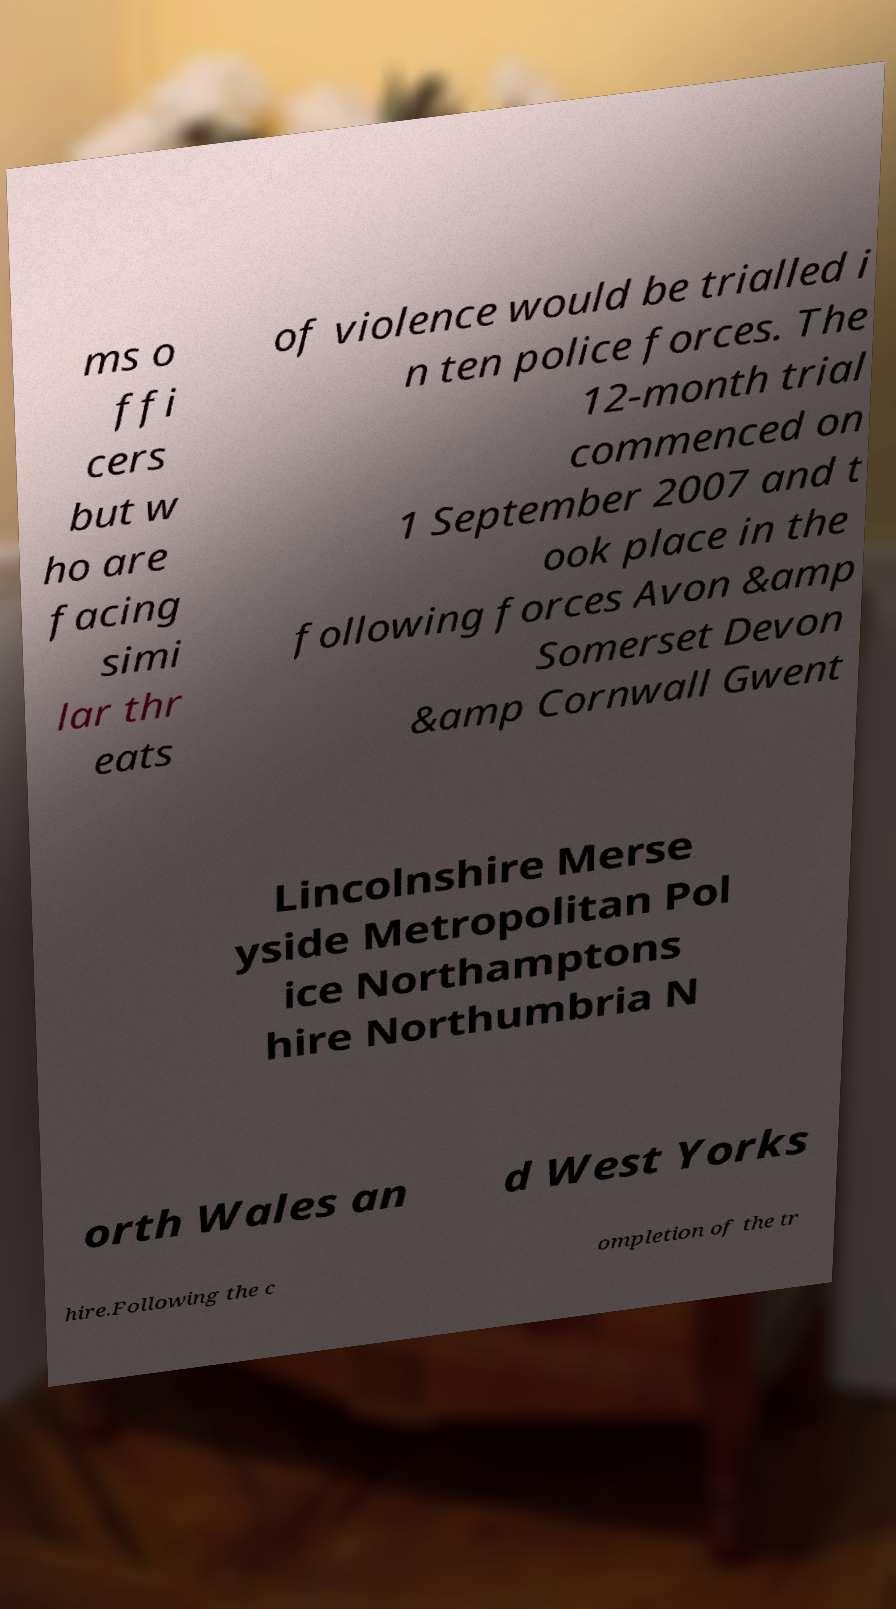Please read and relay the text visible in this image. What does it say? ms o ffi cers but w ho are facing simi lar thr eats of violence would be trialled i n ten police forces. The 12-month trial commenced on 1 September 2007 and t ook place in the following forces Avon &amp Somerset Devon &amp Cornwall Gwent Lincolnshire Merse yside Metropolitan Pol ice Northamptons hire Northumbria N orth Wales an d West Yorks hire.Following the c ompletion of the tr 